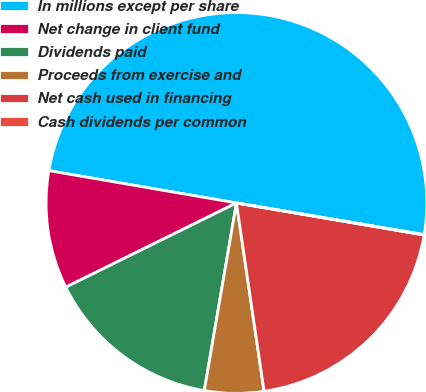Convert chart. <chart><loc_0><loc_0><loc_500><loc_500><pie_chart><fcel>In millions except per share<fcel>Net change in client fund<fcel>Dividends paid<fcel>Proceeds from exercise and<fcel>Net cash used in financing<fcel>Cash dividends per common<nl><fcel>49.94%<fcel>10.01%<fcel>15.0%<fcel>5.02%<fcel>19.99%<fcel>0.03%<nl></chart> 